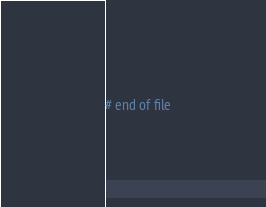<code> <loc_0><loc_0><loc_500><loc_500><_ObjectiveC_>
# end of file
</code> 